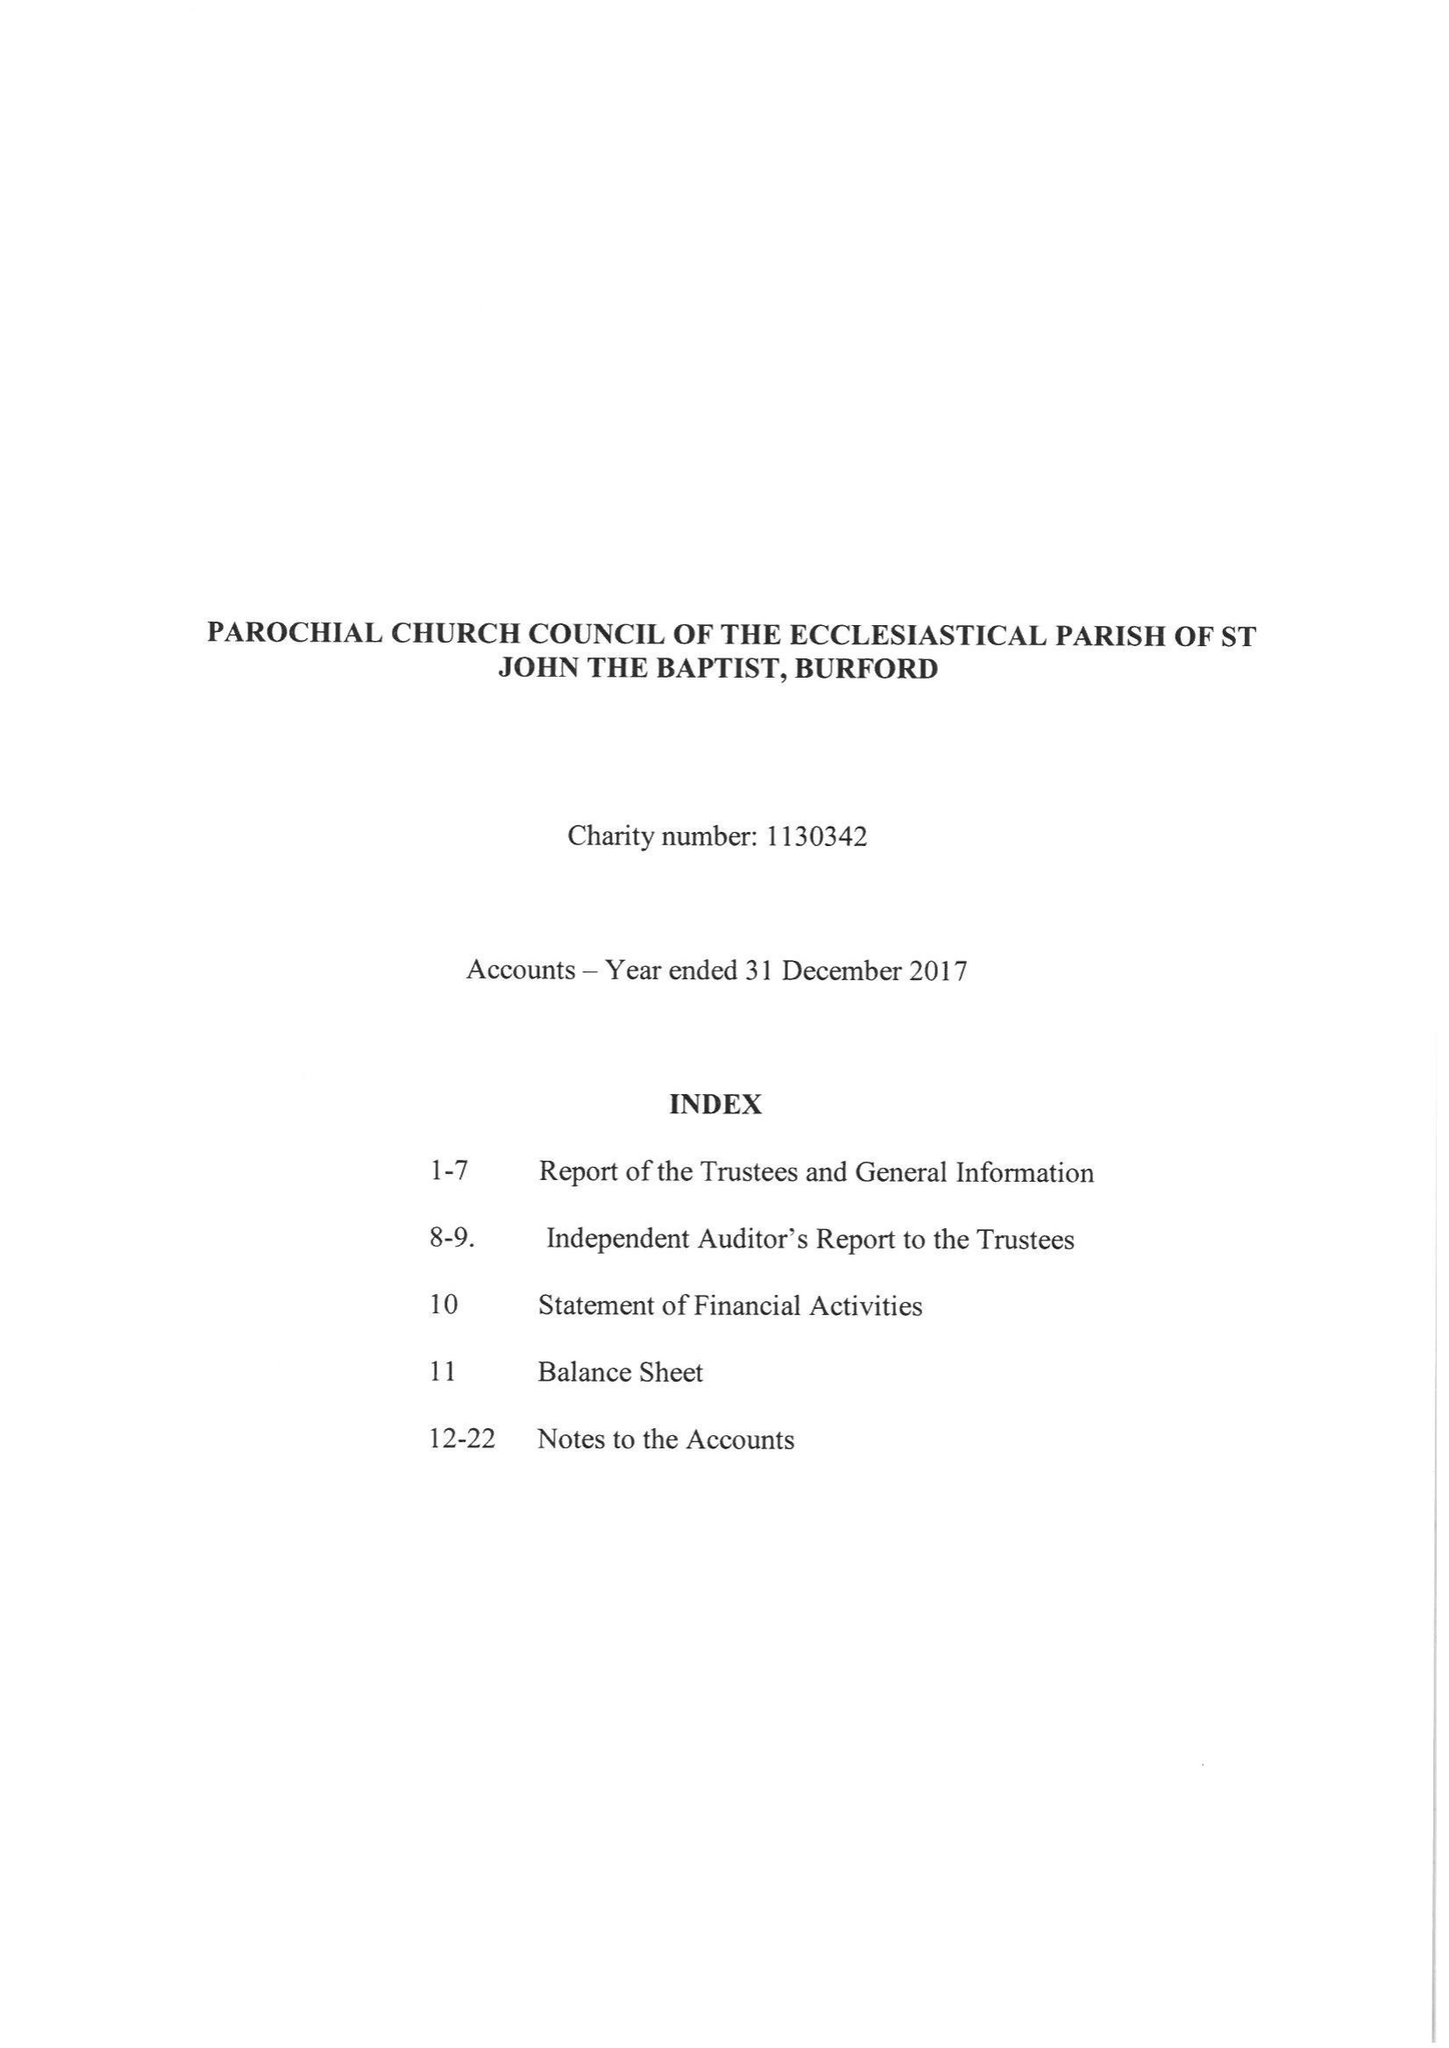What is the value for the charity_number?
Answer the question using a single word or phrase. 1130342 